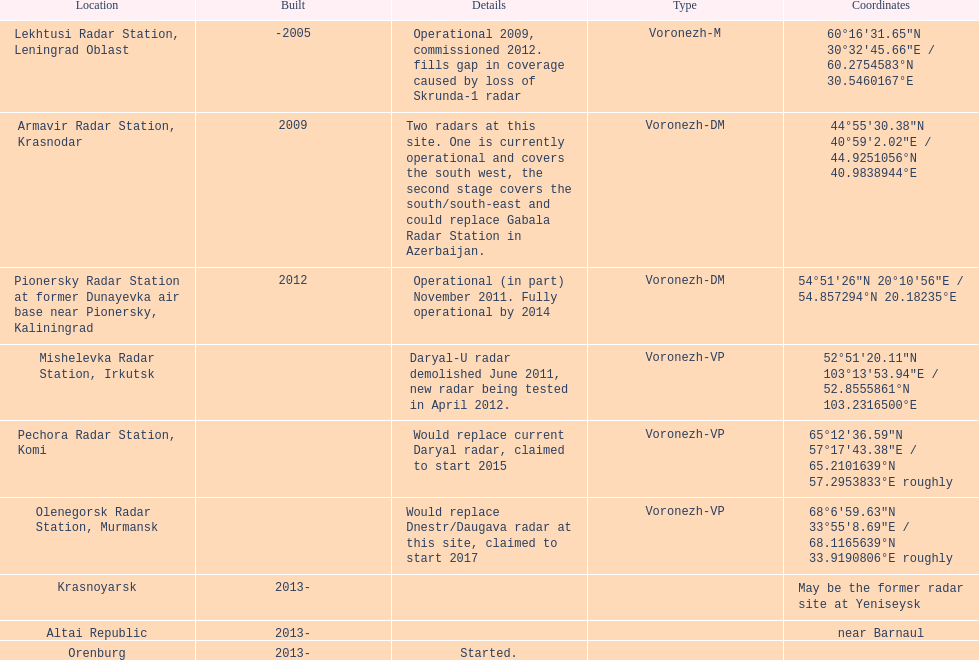What is the total number of locations? 9. 